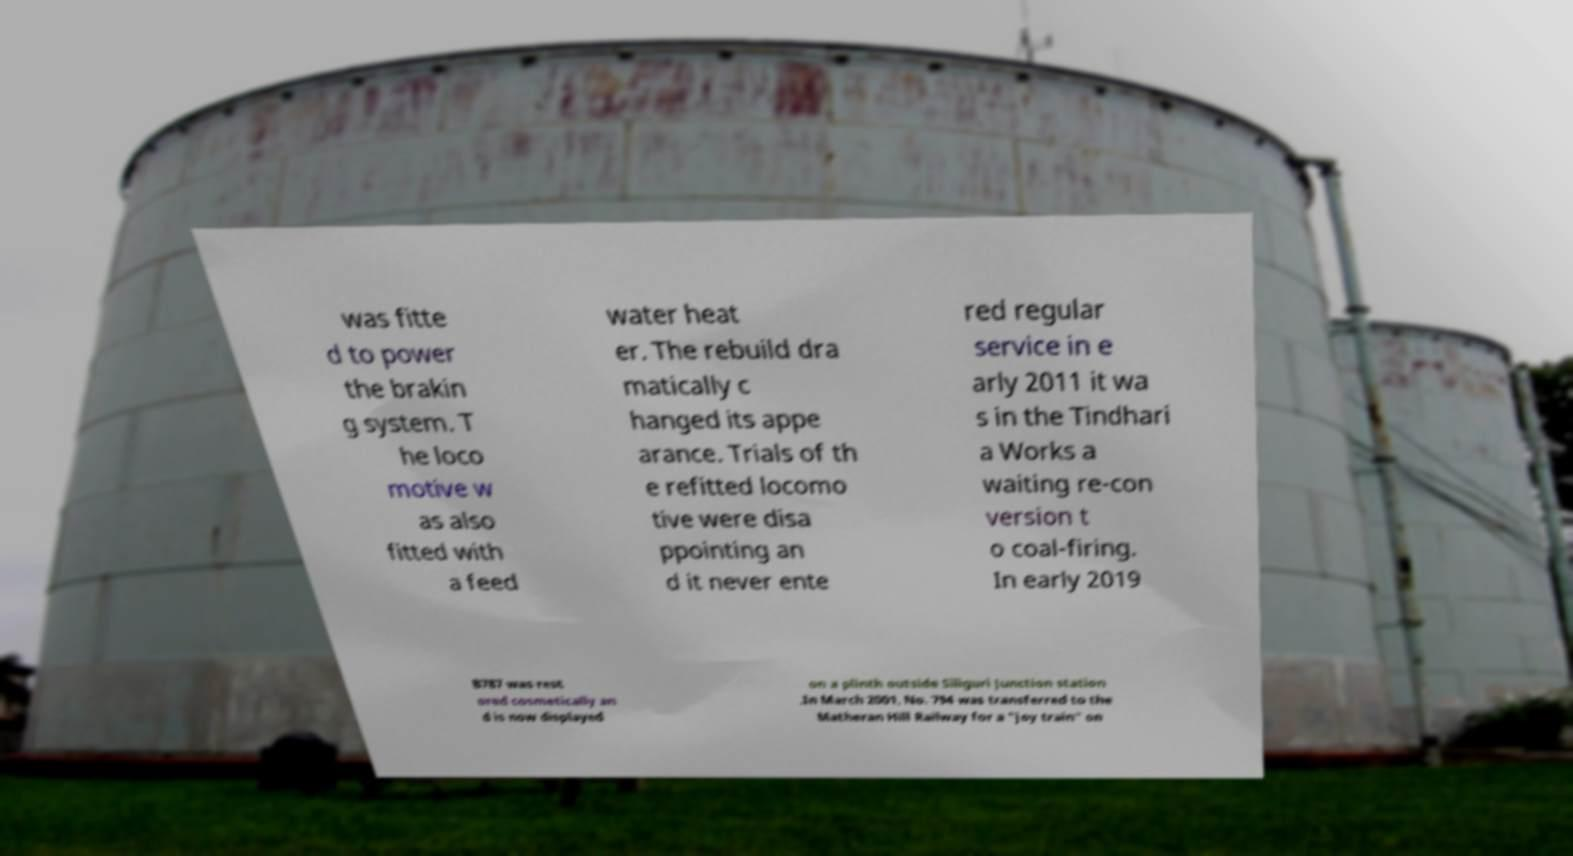There's text embedded in this image that I need extracted. Can you transcribe it verbatim? was fitte d to power the brakin g system. T he loco motive w as also fitted with a feed water heat er. The rebuild dra matically c hanged its appe arance. Trials of th e refitted locomo tive were disa ppointing an d it never ente red regular service in e arly 2011 it wa s in the Tindhari a Works a waiting re-con version t o coal-firing. In early 2019 B787 was rest ored cosmetically an d is now displayed on a plinth outside Siliguri Junction station .In March 2001, No. 794 was transferred to the Matheran Hill Railway for a "joy train" on 